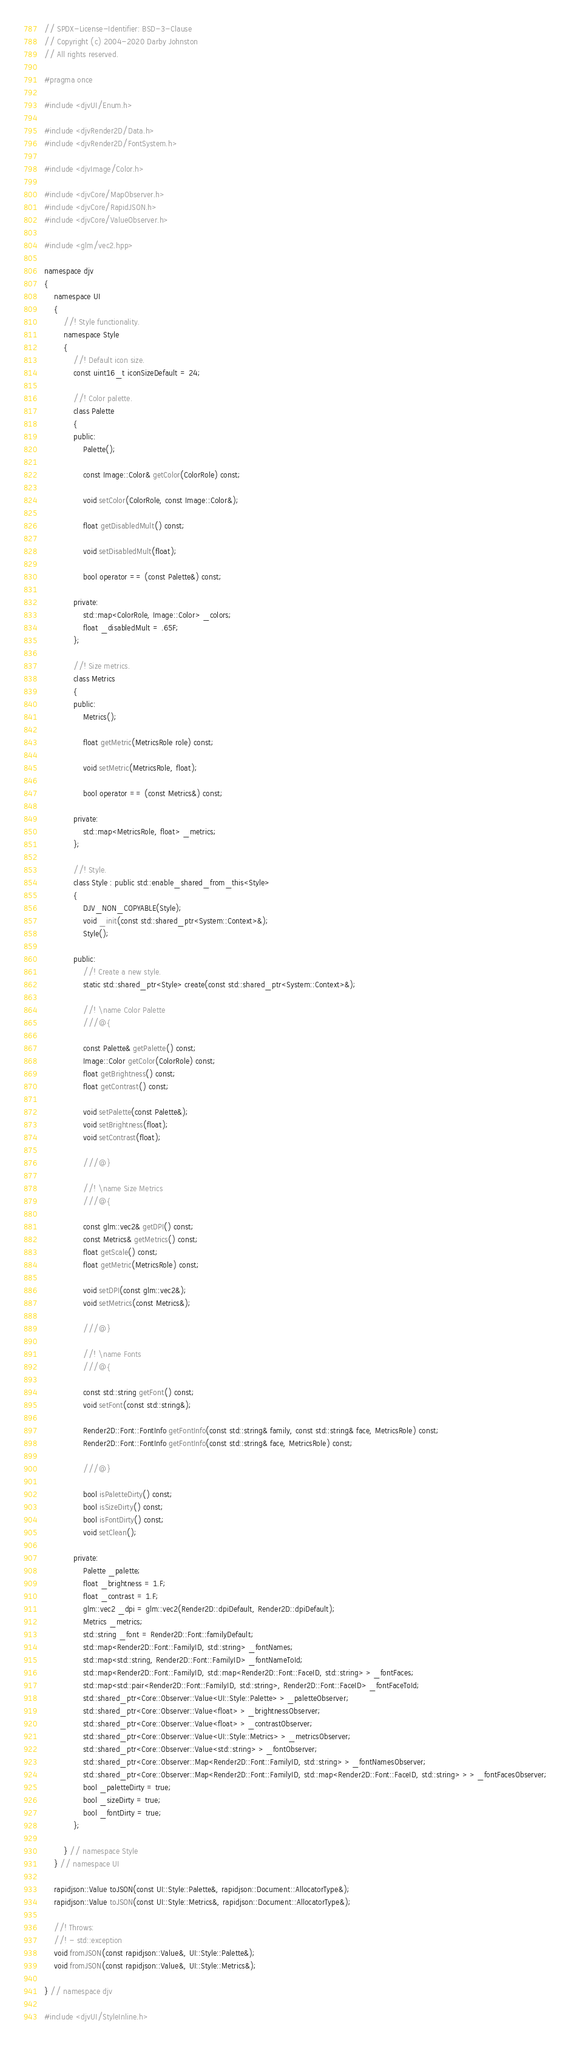<code> <loc_0><loc_0><loc_500><loc_500><_C_>// SPDX-License-Identifier: BSD-3-Clause
// Copyright (c) 2004-2020 Darby Johnston
// All rights reserved.

#pragma once

#include <djvUI/Enum.h>

#include <djvRender2D/Data.h>
#include <djvRender2D/FontSystem.h>

#include <djvImage/Color.h>

#include <djvCore/MapObserver.h>
#include <djvCore/RapidJSON.h>
#include <djvCore/ValueObserver.h>

#include <glm/vec2.hpp>

namespace djv
{
    namespace UI
    {
        //! Style functionality.
        namespace Style
        {
            //! Default icon size.
            const uint16_t iconSizeDefault = 24;

            //! Color palette.
            class Palette
            {
            public:
                Palette();

                const Image::Color& getColor(ColorRole) const;

                void setColor(ColorRole, const Image::Color&);

                float getDisabledMult() const;

                void setDisabledMult(float);

                bool operator == (const Palette&) const;

            private:
                std::map<ColorRole, Image::Color> _colors;
                float _disabledMult = .65F;
            };

            //! Size metrics.
            class Metrics
            {
            public:
                Metrics();

                float getMetric(MetricsRole role) const;

                void setMetric(MetricsRole, float);

                bool operator == (const Metrics&) const;

            private:
                std::map<MetricsRole, float> _metrics;
            };

            //! Style.
            class Style : public std::enable_shared_from_this<Style>
            {
                DJV_NON_COPYABLE(Style);
                void _init(const std::shared_ptr<System::Context>&);
                Style();

            public:
                //! Create a new style.
                static std::shared_ptr<Style> create(const std::shared_ptr<System::Context>&);

                //! \name Color Palette
                ///@{

                const Palette& getPalette() const;
                Image::Color getColor(ColorRole) const;
                float getBrightness() const;
                float getContrast() const;

                void setPalette(const Palette&);
                void setBrightness(float);
                void setContrast(float);

                ///@}

                //! \name Size Metrics
                ///@{

                const glm::vec2& getDPI() const;
                const Metrics& getMetrics() const;
                float getScale() const;
                float getMetric(MetricsRole) const;

                void setDPI(const glm::vec2&);
                void setMetrics(const Metrics&);

                ///@}

                //! \name Fonts
                ///@{

                const std::string getFont() const;
                void setFont(const std::string&);

                Render2D::Font::FontInfo getFontInfo(const std::string& family, const std::string& face, MetricsRole) const;
                Render2D::Font::FontInfo getFontInfo(const std::string& face, MetricsRole) const;

                ///@}

                bool isPaletteDirty() const;
                bool isSizeDirty() const;
                bool isFontDirty() const;
                void setClean();

            private:
                Palette _palette;
                float _brightness = 1.F;
                float _contrast = 1.F;
                glm::vec2 _dpi = glm::vec2(Render2D::dpiDefault, Render2D::dpiDefault);
                Metrics _metrics;
                std::string _font = Render2D::Font::familyDefault;
                std::map<Render2D::Font::FamilyID, std::string> _fontNames;
                std::map<std::string, Render2D::Font::FamilyID> _fontNameToId;
                std::map<Render2D::Font::FamilyID, std::map<Render2D::Font::FaceID, std::string> > _fontFaces;
                std::map<std::pair<Render2D::Font::FamilyID, std::string>, Render2D::Font::FaceID> _fontFaceToId;
                std::shared_ptr<Core::Observer::Value<UI::Style::Palette> > _paletteObserver;
                std::shared_ptr<Core::Observer::Value<float> > _brightnessObserver;
                std::shared_ptr<Core::Observer::Value<float> > _contrastObserver;
                std::shared_ptr<Core::Observer::Value<UI::Style::Metrics> > _metricsObserver;
                std::shared_ptr<Core::Observer::Value<std::string> > _fontObserver;
                std::shared_ptr<Core::Observer::Map<Render2D::Font::FamilyID, std::string> > _fontNamesObserver;
                std::shared_ptr<Core::Observer::Map<Render2D::Font::FamilyID, std::map<Render2D::Font::FaceID, std::string> > > _fontFacesObserver;
                bool _paletteDirty = true;
                bool _sizeDirty = true;
                bool _fontDirty = true;
            };

        } // namespace Style
    } // namespace UI
    
    rapidjson::Value toJSON(const UI::Style::Palette&, rapidjson::Document::AllocatorType&);
    rapidjson::Value toJSON(const UI::Style::Metrics&, rapidjson::Document::AllocatorType&);

    //! Throws:
    //! - std::exception
    void fromJSON(const rapidjson::Value&, UI::Style::Palette&);
    void fromJSON(const rapidjson::Value&, UI::Style::Metrics&);
    
} // namespace djv

#include <djvUI/StyleInline.h>
</code> 